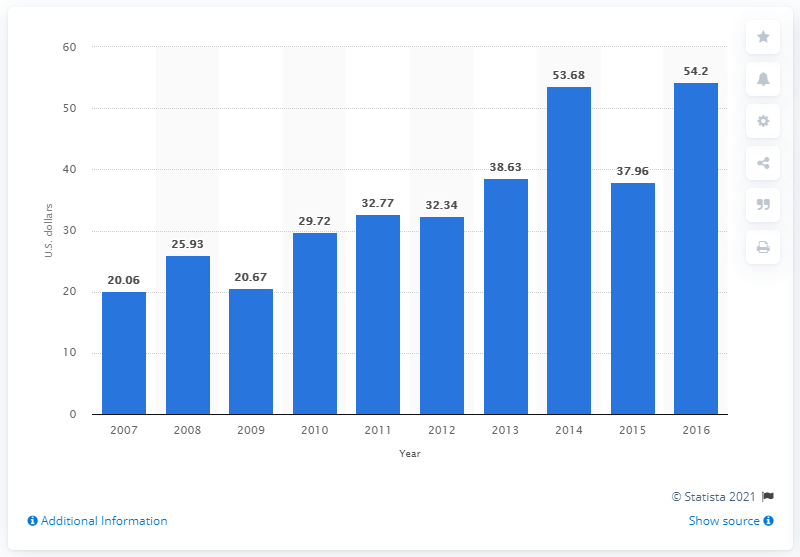Point out several critical features in this image. In 2014, the average consumer expected to spend $53.68 on Valentine's Day gifts for their co-workers. 